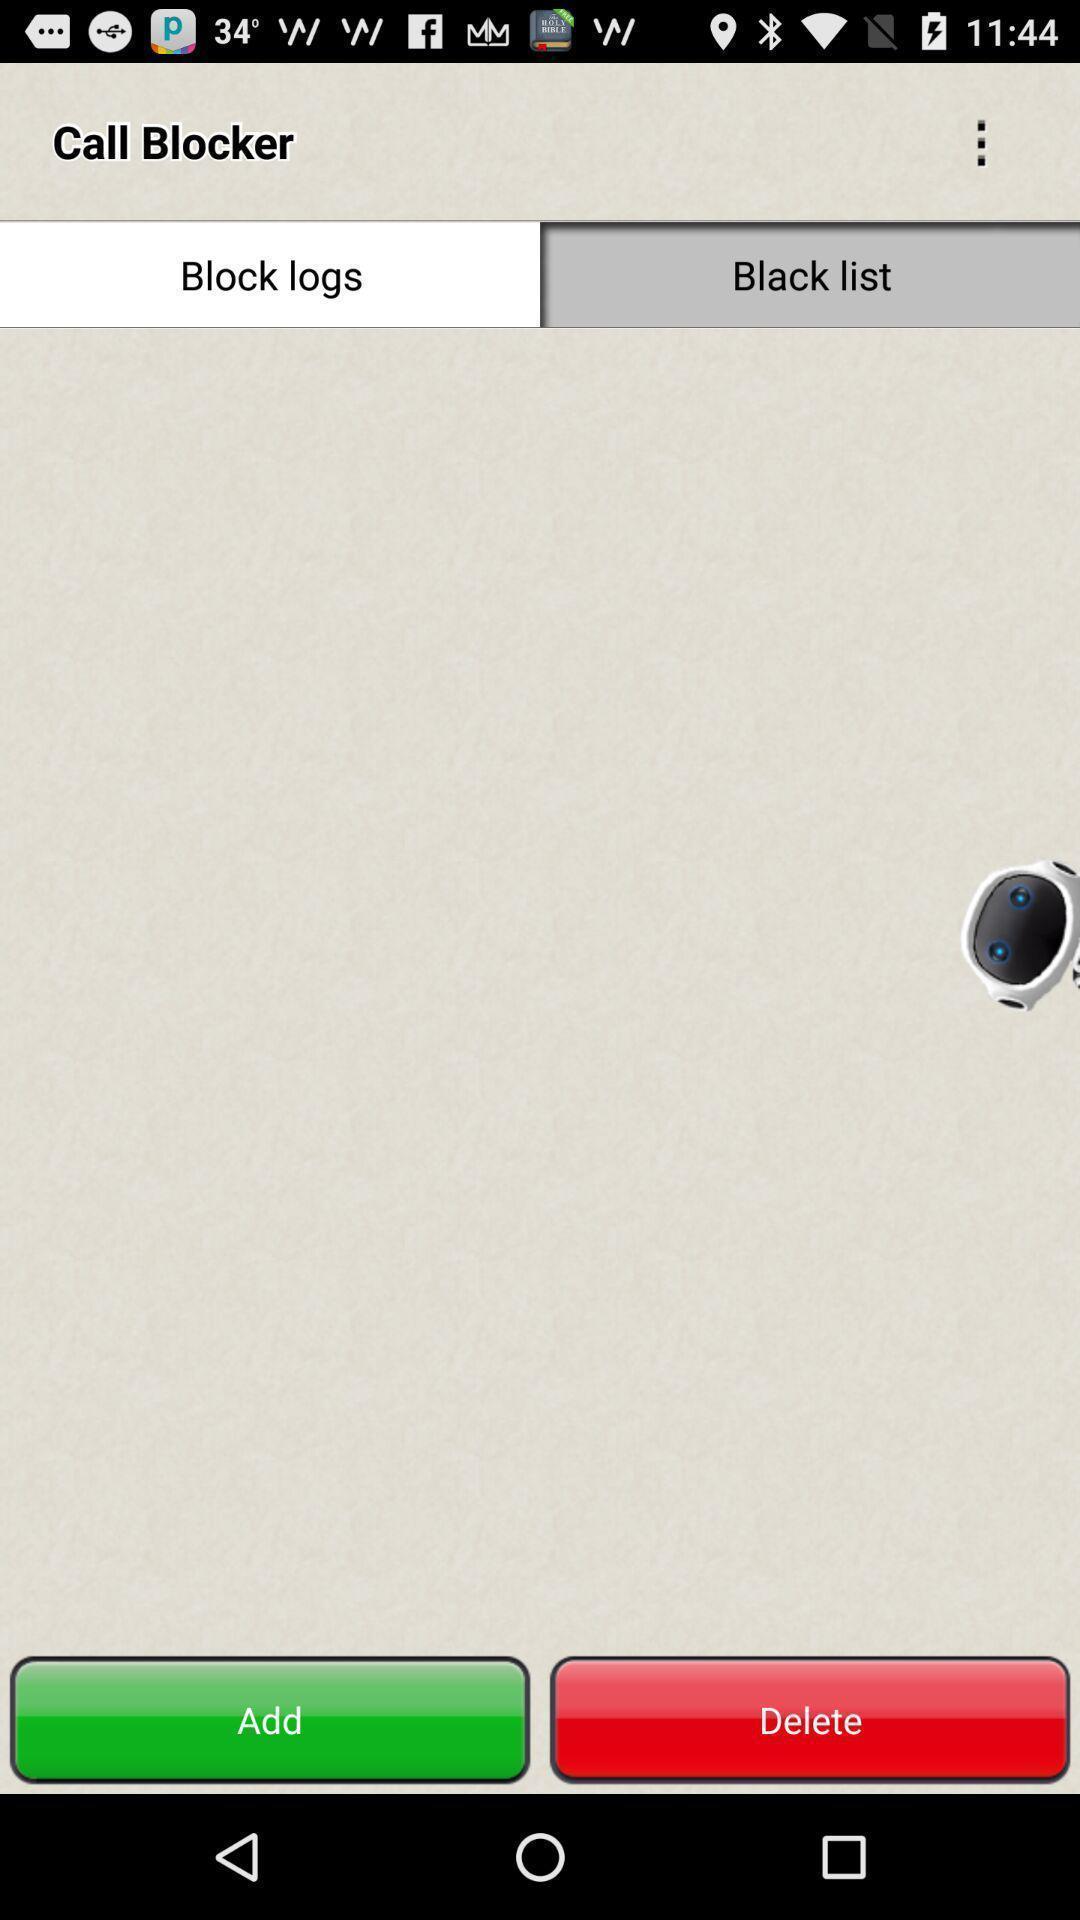Provide a description of this screenshot. Screen displaying black list page. 